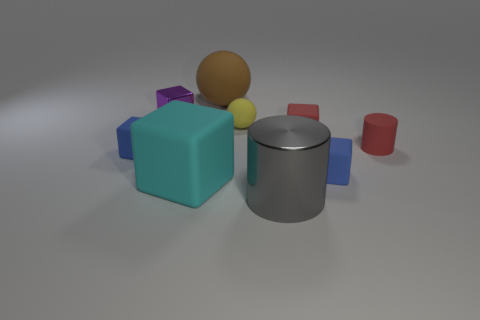Subtract all big rubber cubes. How many cubes are left? 4 Subtract all blue cubes. How many cubes are left? 3 Subtract all cyan cylinders. How many blue blocks are left? 2 Subtract 3 cubes. How many cubes are left? 2 Add 1 cyan matte objects. How many objects exist? 10 Subtract all cylinders. How many objects are left? 7 Subtract all green blocks. Subtract all cyan cylinders. How many blocks are left? 5 Subtract 1 purple blocks. How many objects are left? 8 Subtract all red things. Subtract all cyan cubes. How many objects are left? 6 Add 5 large gray objects. How many large gray objects are left? 6 